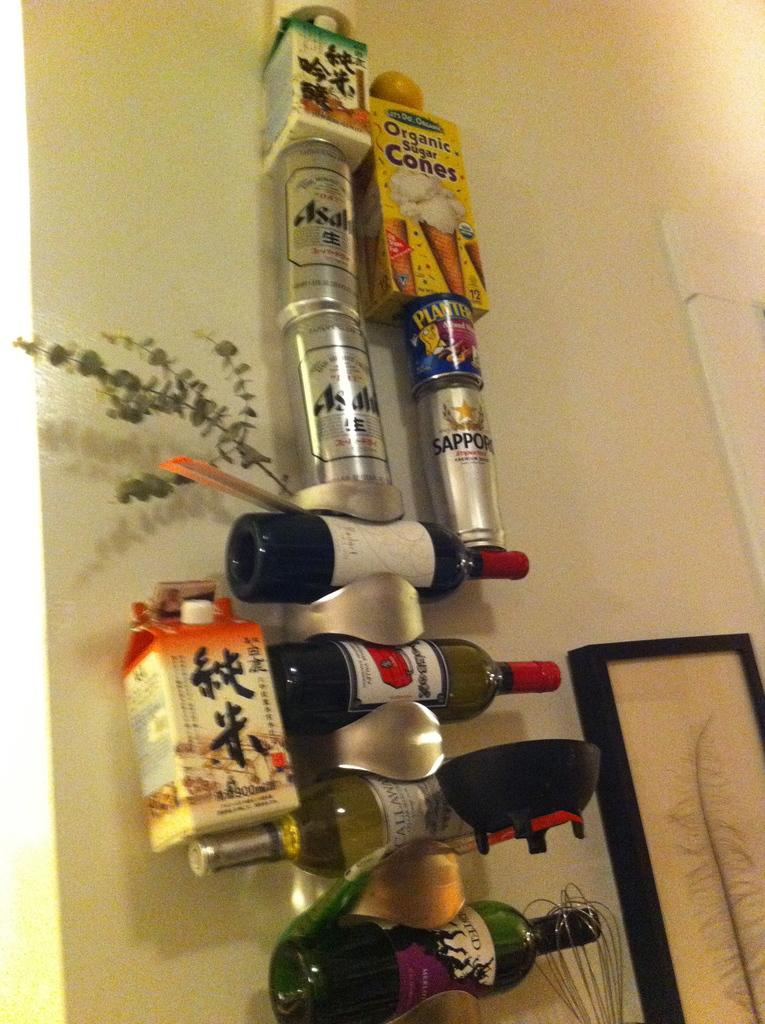What objects are hanging in the image? There are bottles and tins hanging in the image. What kitchen utensil can be seen in the image? There is a whisk visible in the image. What type of decorative item is present in the image? There is a photo frame in the image. What type of surface is visible in the image? There is a wall visible in the image. Can you see any matches or toes in the image? No, there are no matches or toes present in the image. Are there any cherries hanging alongside the bottles and tins in the image? No, there are no cherries visible in the image. 